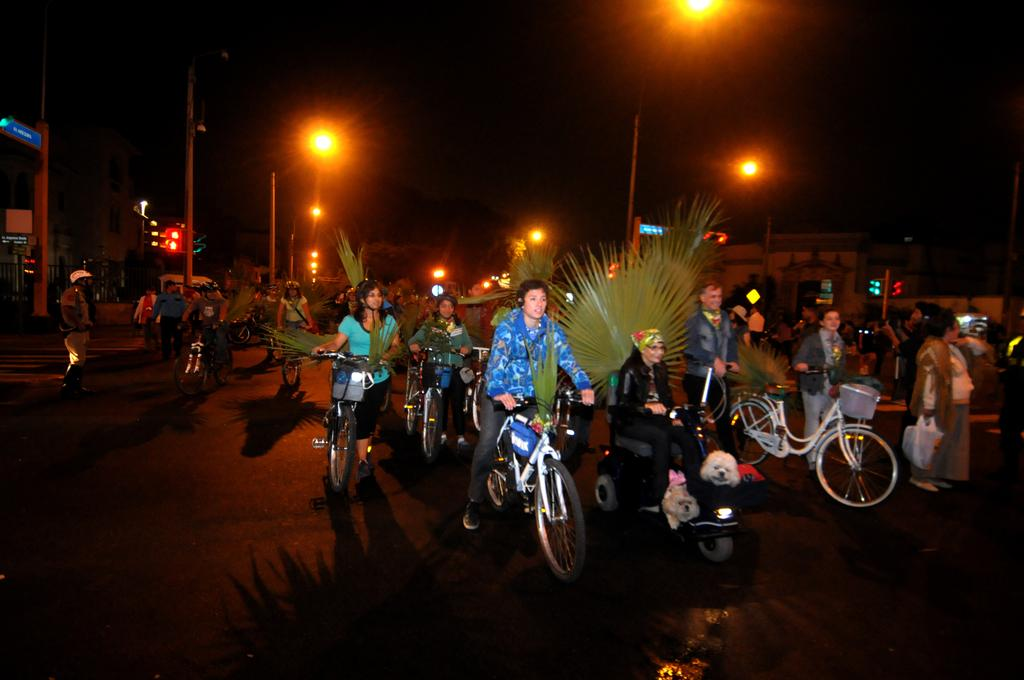What are the people in the image doing? The people in the image are riding bicycles or walking and holding the handle of a bicycle. What can be seen in the background of the image? There are street lights and buildings in the background of the image. What type of school can be seen in the image? There is no school present in the image. What kind of shop is visible in the image? There is no shop visible in the image. 